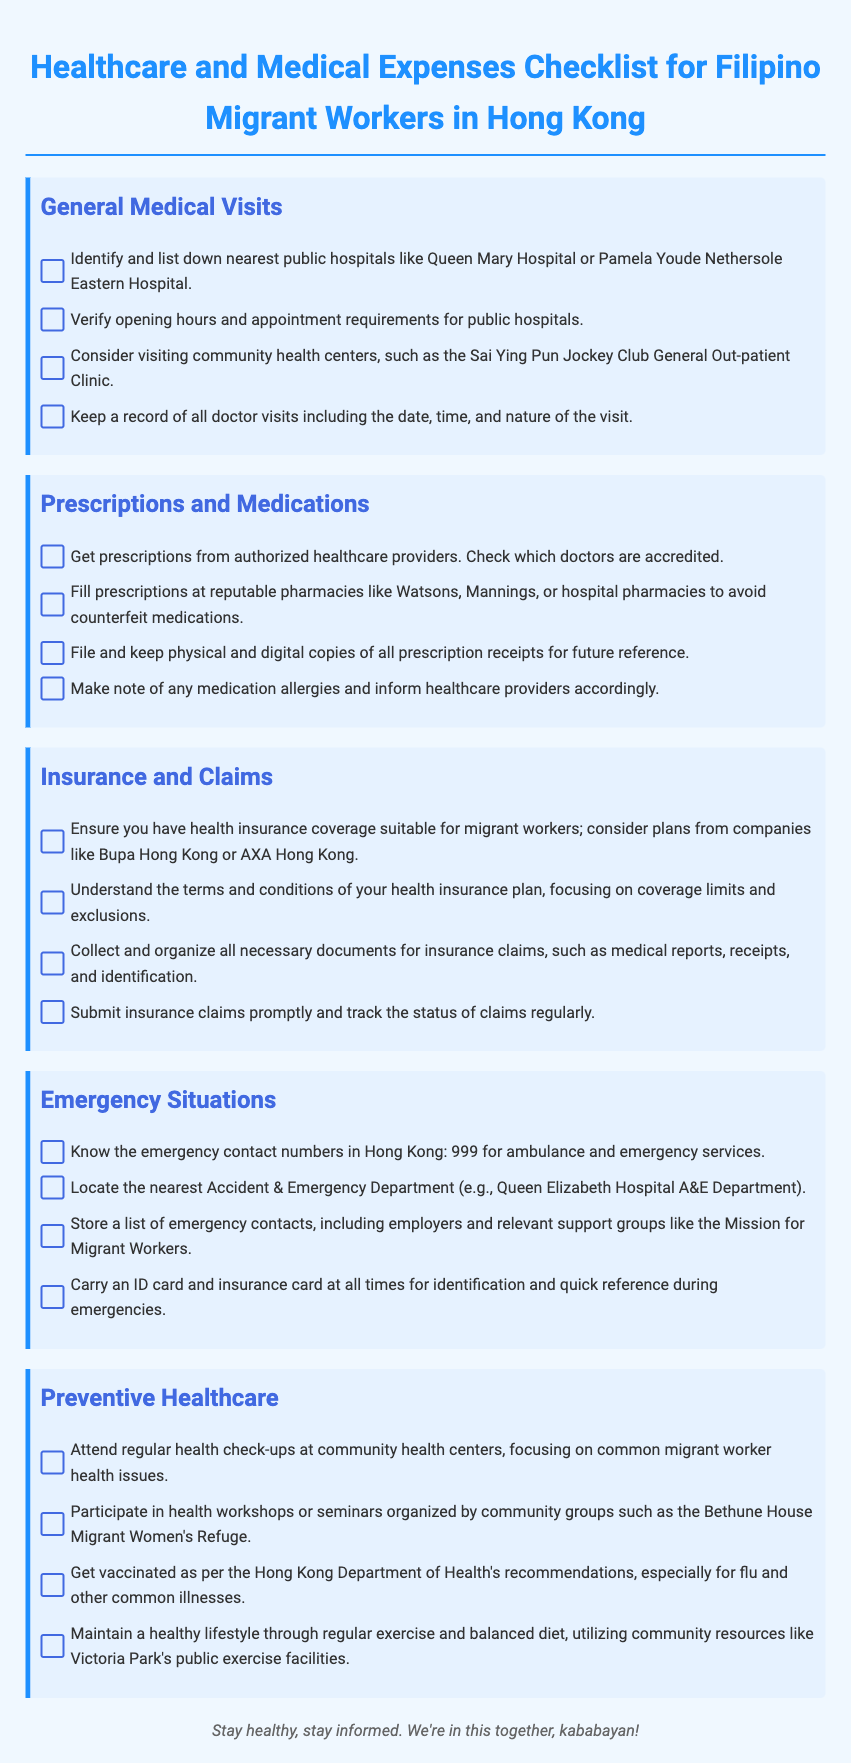what are the names of two public hospitals mentioned? The document lists Queen Mary Hospital and Pamela Youde Nethersole Eastern Hospital as public hospitals.
Answer: Queen Mary Hospital, Pamela Youde Nethersole Eastern Hospital what should you verify about public hospitals? The document states the need to verify opening hours and appointment requirements for public hospitals.
Answer: Opening hours and appointment requirements which pharmacies are recommended for filling prescriptions? The checklist suggests filling prescriptions at pharmacies like Watsons, Mannings, or hospital pharmacies to avoid counterfeit medications.
Answer: Watsons, Mannings, hospital pharmacies what is essential to keep for insurance claims? The document lists medical reports, receipts, and identification as necessary documents for insurance claims.
Answer: Medical reports, receipts, identification how often should you attend health check-ups according to the checklist? The document advises attending regular health check-ups at community health centers.
Answer: Regularly what are the emergency contact numbers for Hong Kong? The document mentions that the emergency contact number for ambulance and emergency services is 999.
Answer: 999 which health insurance companies are recommended? The checklist recommends health insurance plans from companies like Bupa Hong Kong or AXA Hong Kong.
Answer: Bupa Hong Kong, AXA Hong Kong what kind of health workshops should you attend? The document suggests participating in health workshops or seminars organized by community groups such as the Bethune House Migrant Women's Refuge.
Answer: Health workshops where can you find preventive healthcare resources? The document indicates that community resources like Victoria Park's public exercise facilities can be utilized for a healthy lifestyle.
Answer: Victoria Park's public exercise facilities 